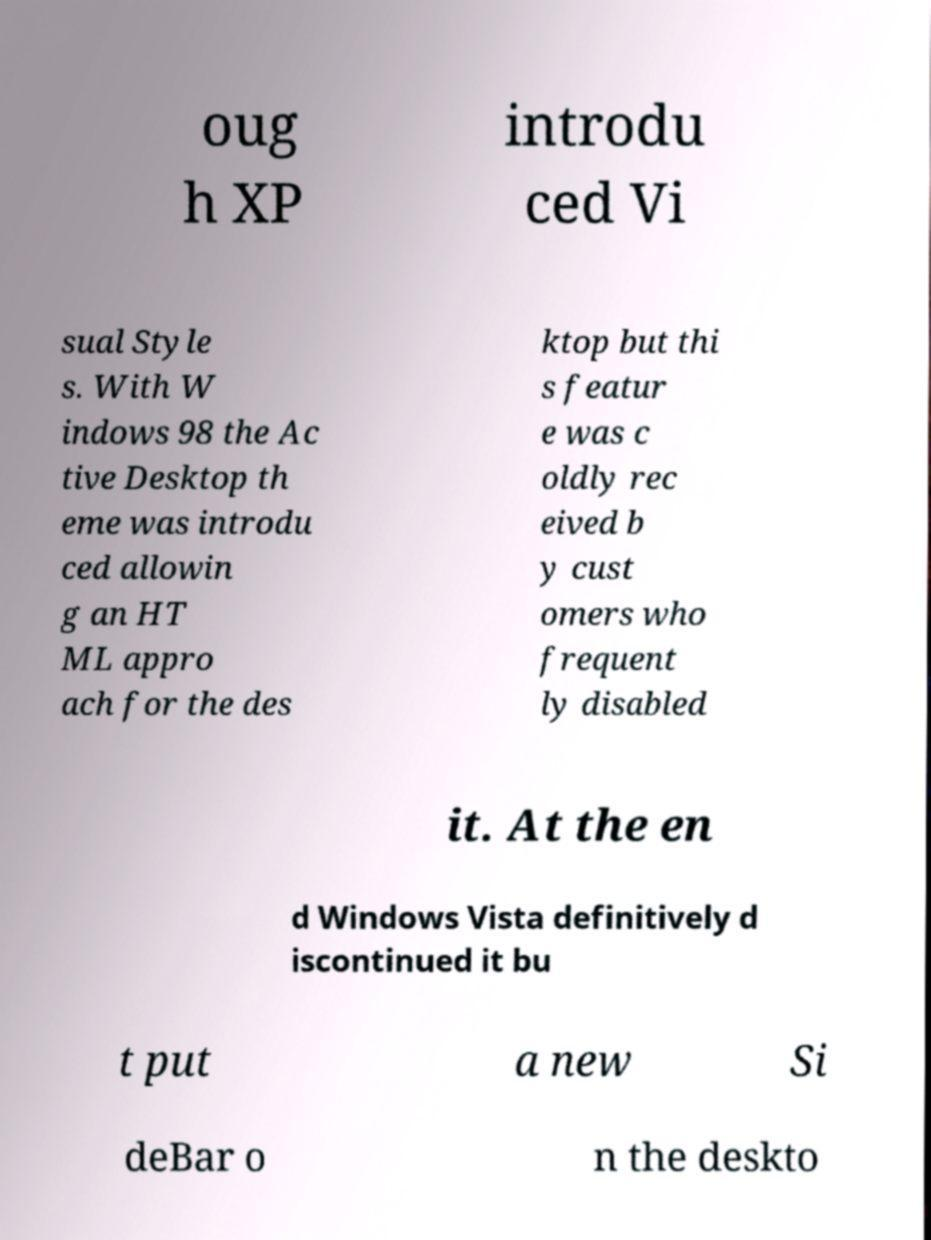Please read and relay the text visible in this image. What does it say? oug h XP introdu ced Vi sual Style s. With W indows 98 the Ac tive Desktop th eme was introdu ced allowin g an HT ML appro ach for the des ktop but thi s featur e was c oldly rec eived b y cust omers who frequent ly disabled it. At the en d Windows Vista definitively d iscontinued it bu t put a new Si deBar o n the deskto 